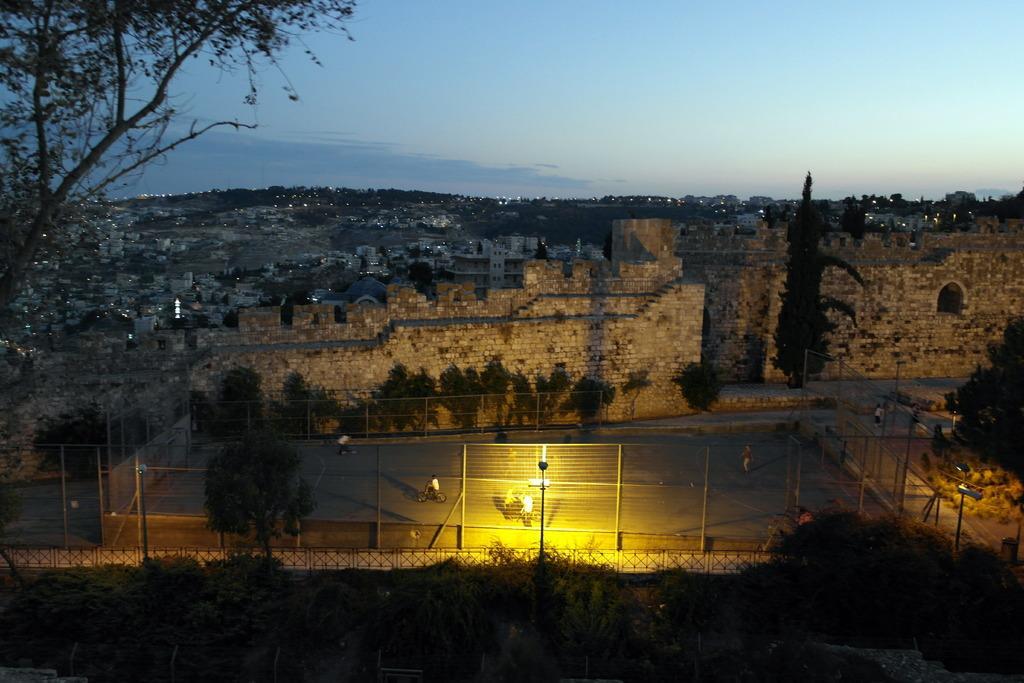Please provide a concise description of this image. In this image we can see people riding bicycles and there is a mesh. In the background there are trees, buildings, hills and sky. We can see a fort and there are lights. 